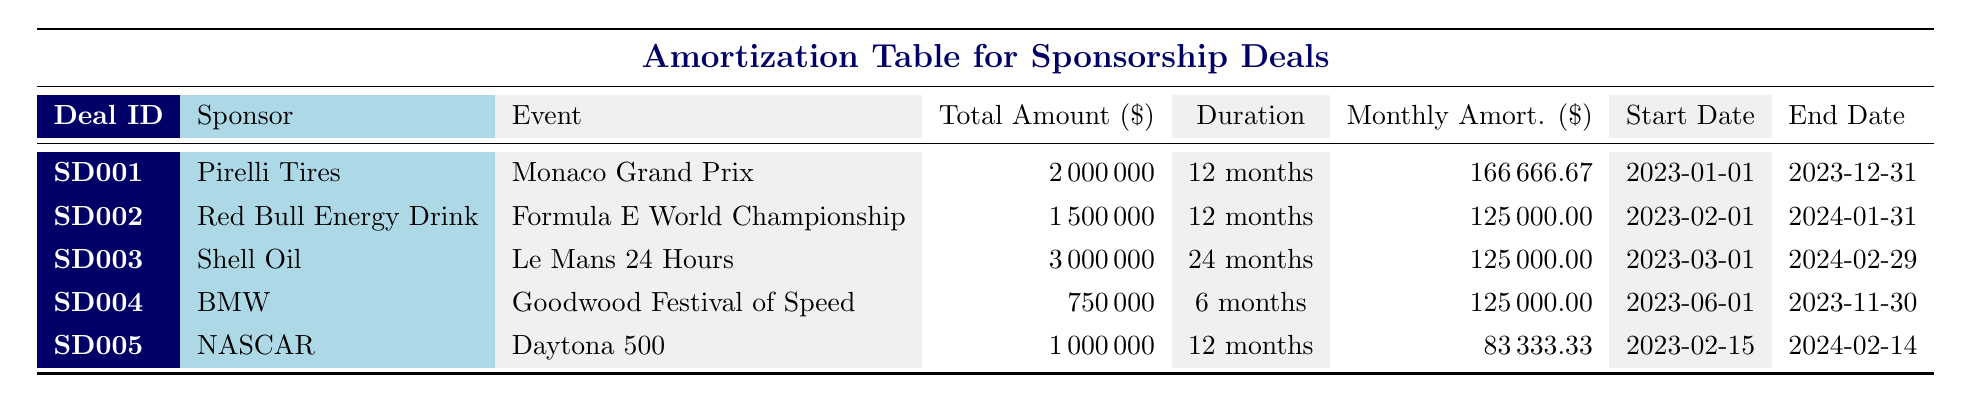What is the total deal amount for the sponsorship deal with NASCAR? The table shows that the deal ID for NASCAR is SD005, and under the "Total Amount" column, it lists the value as 1000000.
Answer: 1000000 How long is the sponsorship duration for Pirelli Tires? Referring to the row for Pirelli Tires (SD001), the "Duration" column specifies 12 months.
Answer: 12 months Which sponsorship deal has the highest total deal amount? By comparing the "Total Amount" values in the table, Shell Oil has the highest total deal amount of 3000000.
Answer: Shell Oil What is the average monthly amortization amount for all sponsorship deals? To calculate the average, sum the monthly amortizations (166666.67 + 125000 + 125000 + 125000 + 83333.33 = 666666.67) and divide by the number of deals (5), resulting in 666666.67 / 5 = 133333.33.
Answer: 133333.33 Is the total deal amount for the Monaco Grand Prix greater than 1 million dollars? The total deal amount for the Monaco Grand Prix (SD001) is listed as 2000000, which is greater than 1 million.
Answer: Yes What is the duration of the sponsorship deal for the Goodwood Festival of Speed, and how does it compare to the other deals? The duration for BMW's deal for the Goodwood Festival of Speed (SD004) is 6 months. Comparing this with other deals shows it's the shortest duration among the listed deals.
Answer: 6 months (shortest duration of all deals) Which sponsor has the most extended duration for their sponsorship deal? Reviewing the durations, Shell Oil's deal (SD003) lasts for 24 months, making it the longest compared to the others.
Answer: Shell Oil What is the total deal amount for both the Daytona 500 and Formula E World Championship combined? The total amounts for Daytona 500 (SD005) and Formula E World Championship (SD002) are 1000000 and 1500000 respectively. Adding these gives 1000000 + 1500000 = 2500000.
Answer: 2500000 Are all sponsorship deals for events within the year 2023? Upon examining the start and end dates, it is apparent that Red Bull Energy Drink's deal ends in January 2024, indicating not all are within 2023.
Answer: No 